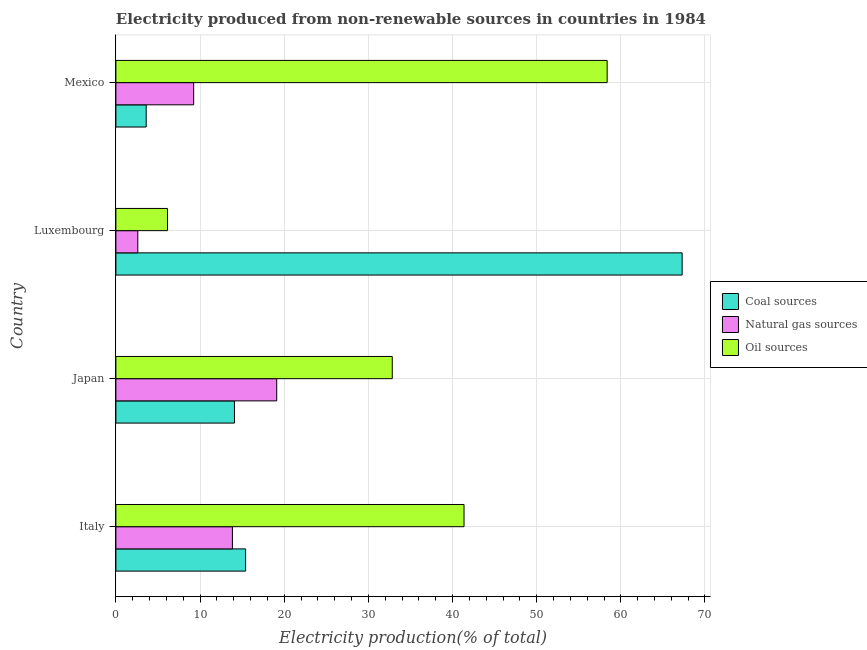How many different coloured bars are there?
Offer a very short reply. 3. How many groups of bars are there?
Provide a succinct answer. 4. Are the number of bars per tick equal to the number of legend labels?
Provide a short and direct response. Yes. What is the label of the 2nd group of bars from the top?
Your answer should be compact. Luxembourg. What is the percentage of electricity produced by natural gas in Mexico?
Ensure brevity in your answer.  9.24. Across all countries, what is the maximum percentage of electricity produced by oil sources?
Provide a succinct answer. 58.37. Across all countries, what is the minimum percentage of electricity produced by coal?
Your response must be concise. 3.6. In which country was the percentage of electricity produced by coal maximum?
Your response must be concise. Luxembourg. In which country was the percentage of electricity produced by coal minimum?
Ensure brevity in your answer.  Mexico. What is the total percentage of electricity produced by oil sources in the graph?
Your answer should be very brief. 138.72. What is the difference between the percentage of electricity produced by oil sources in Japan and that in Luxembourg?
Offer a terse response. 26.71. What is the difference between the percentage of electricity produced by natural gas in Luxembourg and the percentage of electricity produced by oil sources in Italy?
Offer a terse response. -38.77. What is the average percentage of electricity produced by natural gas per country?
Your response must be concise. 11.2. What is the difference between the percentage of electricity produced by coal and percentage of electricity produced by natural gas in Luxembourg?
Give a very brief answer. 64.68. What is the ratio of the percentage of electricity produced by coal in Japan to that in Luxembourg?
Give a very brief answer. 0.21. Is the percentage of electricity produced by natural gas in Japan less than that in Mexico?
Offer a very short reply. No. What is the difference between the highest and the second highest percentage of electricity produced by coal?
Ensure brevity in your answer.  51.87. What is the difference between the highest and the lowest percentage of electricity produced by oil sources?
Give a very brief answer. 52.24. In how many countries, is the percentage of electricity produced by natural gas greater than the average percentage of electricity produced by natural gas taken over all countries?
Provide a succinct answer. 2. Is the sum of the percentage of electricity produced by coal in Japan and Mexico greater than the maximum percentage of electricity produced by oil sources across all countries?
Offer a terse response. No. What does the 2nd bar from the top in Japan represents?
Provide a short and direct response. Natural gas sources. What does the 2nd bar from the bottom in Italy represents?
Keep it short and to the point. Natural gas sources. Is it the case that in every country, the sum of the percentage of electricity produced by coal and percentage of electricity produced by natural gas is greater than the percentage of electricity produced by oil sources?
Keep it short and to the point. No. Does the graph contain any zero values?
Your response must be concise. No. How many legend labels are there?
Give a very brief answer. 3. What is the title of the graph?
Ensure brevity in your answer.  Electricity produced from non-renewable sources in countries in 1984. What is the label or title of the Y-axis?
Offer a very short reply. Country. What is the Electricity production(% of total) of Coal sources in Italy?
Your answer should be very brief. 15.41. What is the Electricity production(% of total) in Natural gas sources in Italy?
Your answer should be very brief. 13.85. What is the Electricity production(% of total) in Oil sources in Italy?
Make the answer very short. 41.37. What is the Electricity production(% of total) in Coal sources in Japan?
Your response must be concise. 14.09. What is the Electricity production(% of total) in Natural gas sources in Japan?
Offer a terse response. 19.11. What is the Electricity production(% of total) of Oil sources in Japan?
Offer a very short reply. 32.84. What is the Electricity production(% of total) in Coal sources in Luxembourg?
Give a very brief answer. 67.29. What is the Electricity production(% of total) in Natural gas sources in Luxembourg?
Your answer should be very brief. 2.6. What is the Electricity production(% of total) in Oil sources in Luxembourg?
Ensure brevity in your answer.  6.13. What is the Electricity production(% of total) in Coal sources in Mexico?
Make the answer very short. 3.6. What is the Electricity production(% of total) of Natural gas sources in Mexico?
Offer a very short reply. 9.24. What is the Electricity production(% of total) in Oil sources in Mexico?
Offer a terse response. 58.37. Across all countries, what is the maximum Electricity production(% of total) in Coal sources?
Ensure brevity in your answer.  67.29. Across all countries, what is the maximum Electricity production(% of total) in Natural gas sources?
Provide a succinct answer. 19.11. Across all countries, what is the maximum Electricity production(% of total) in Oil sources?
Your response must be concise. 58.37. Across all countries, what is the minimum Electricity production(% of total) of Coal sources?
Ensure brevity in your answer.  3.6. Across all countries, what is the minimum Electricity production(% of total) of Natural gas sources?
Ensure brevity in your answer.  2.6. Across all countries, what is the minimum Electricity production(% of total) of Oil sources?
Offer a very short reply. 6.13. What is the total Electricity production(% of total) in Coal sources in the graph?
Make the answer very short. 100.39. What is the total Electricity production(% of total) of Natural gas sources in the graph?
Your answer should be very brief. 44.8. What is the total Electricity production(% of total) of Oil sources in the graph?
Provide a succinct answer. 138.72. What is the difference between the Electricity production(% of total) in Coal sources in Italy and that in Japan?
Ensure brevity in your answer.  1.33. What is the difference between the Electricity production(% of total) of Natural gas sources in Italy and that in Japan?
Provide a short and direct response. -5.26. What is the difference between the Electricity production(% of total) in Oil sources in Italy and that in Japan?
Your answer should be compact. 8.53. What is the difference between the Electricity production(% of total) of Coal sources in Italy and that in Luxembourg?
Provide a short and direct response. -51.87. What is the difference between the Electricity production(% of total) of Natural gas sources in Italy and that in Luxembourg?
Your answer should be very brief. 11.24. What is the difference between the Electricity production(% of total) of Oil sources in Italy and that in Luxembourg?
Provide a succinct answer. 35.23. What is the difference between the Electricity production(% of total) of Coal sources in Italy and that in Mexico?
Ensure brevity in your answer.  11.81. What is the difference between the Electricity production(% of total) of Natural gas sources in Italy and that in Mexico?
Give a very brief answer. 4.6. What is the difference between the Electricity production(% of total) in Oil sources in Italy and that in Mexico?
Keep it short and to the point. -17.01. What is the difference between the Electricity production(% of total) of Coal sources in Japan and that in Luxembourg?
Ensure brevity in your answer.  -53.2. What is the difference between the Electricity production(% of total) in Natural gas sources in Japan and that in Luxembourg?
Keep it short and to the point. 16.51. What is the difference between the Electricity production(% of total) in Oil sources in Japan and that in Luxembourg?
Ensure brevity in your answer.  26.71. What is the difference between the Electricity production(% of total) in Coal sources in Japan and that in Mexico?
Provide a short and direct response. 10.49. What is the difference between the Electricity production(% of total) in Natural gas sources in Japan and that in Mexico?
Give a very brief answer. 9.87. What is the difference between the Electricity production(% of total) of Oil sources in Japan and that in Mexico?
Provide a short and direct response. -25.53. What is the difference between the Electricity production(% of total) in Coal sources in Luxembourg and that in Mexico?
Make the answer very short. 63.68. What is the difference between the Electricity production(% of total) in Natural gas sources in Luxembourg and that in Mexico?
Make the answer very short. -6.64. What is the difference between the Electricity production(% of total) in Oil sources in Luxembourg and that in Mexico?
Keep it short and to the point. -52.24. What is the difference between the Electricity production(% of total) of Coal sources in Italy and the Electricity production(% of total) of Natural gas sources in Japan?
Provide a short and direct response. -3.7. What is the difference between the Electricity production(% of total) in Coal sources in Italy and the Electricity production(% of total) in Oil sources in Japan?
Your answer should be compact. -17.43. What is the difference between the Electricity production(% of total) in Natural gas sources in Italy and the Electricity production(% of total) in Oil sources in Japan?
Your answer should be very brief. -18.99. What is the difference between the Electricity production(% of total) of Coal sources in Italy and the Electricity production(% of total) of Natural gas sources in Luxembourg?
Your answer should be compact. 12.81. What is the difference between the Electricity production(% of total) of Coal sources in Italy and the Electricity production(% of total) of Oil sources in Luxembourg?
Make the answer very short. 9.28. What is the difference between the Electricity production(% of total) in Natural gas sources in Italy and the Electricity production(% of total) in Oil sources in Luxembourg?
Your response must be concise. 7.71. What is the difference between the Electricity production(% of total) of Coal sources in Italy and the Electricity production(% of total) of Natural gas sources in Mexico?
Make the answer very short. 6.17. What is the difference between the Electricity production(% of total) in Coal sources in Italy and the Electricity production(% of total) in Oil sources in Mexico?
Provide a succinct answer. -42.96. What is the difference between the Electricity production(% of total) of Natural gas sources in Italy and the Electricity production(% of total) of Oil sources in Mexico?
Your response must be concise. -44.53. What is the difference between the Electricity production(% of total) in Coal sources in Japan and the Electricity production(% of total) in Natural gas sources in Luxembourg?
Your answer should be compact. 11.49. What is the difference between the Electricity production(% of total) of Coal sources in Japan and the Electricity production(% of total) of Oil sources in Luxembourg?
Offer a very short reply. 7.95. What is the difference between the Electricity production(% of total) of Natural gas sources in Japan and the Electricity production(% of total) of Oil sources in Luxembourg?
Offer a terse response. 12.98. What is the difference between the Electricity production(% of total) of Coal sources in Japan and the Electricity production(% of total) of Natural gas sources in Mexico?
Ensure brevity in your answer.  4.85. What is the difference between the Electricity production(% of total) of Coal sources in Japan and the Electricity production(% of total) of Oil sources in Mexico?
Offer a very short reply. -44.29. What is the difference between the Electricity production(% of total) of Natural gas sources in Japan and the Electricity production(% of total) of Oil sources in Mexico?
Ensure brevity in your answer.  -39.26. What is the difference between the Electricity production(% of total) of Coal sources in Luxembourg and the Electricity production(% of total) of Natural gas sources in Mexico?
Keep it short and to the point. 58.04. What is the difference between the Electricity production(% of total) in Coal sources in Luxembourg and the Electricity production(% of total) in Oil sources in Mexico?
Provide a short and direct response. 8.91. What is the difference between the Electricity production(% of total) of Natural gas sources in Luxembourg and the Electricity production(% of total) of Oil sources in Mexico?
Offer a terse response. -55.77. What is the average Electricity production(% of total) of Coal sources per country?
Keep it short and to the point. 25.1. What is the average Electricity production(% of total) in Natural gas sources per country?
Provide a succinct answer. 11.2. What is the average Electricity production(% of total) of Oil sources per country?
Offer a terse response. 34.68. What is the difference between the Electricity production(% of total) in Coal sources and Electricity production(% of total) in Natural gas sources in Italy?
Make the answer very short. 1.57. What is the difference between the Electricity production(% of total) of Coal sources and Electricity production(% of total) of Oil sources in Italy?
Ensure brevity in your answer.  -25.95. What is the difference between the Electricity production(% of total) in Natural gas sources and Electricity production(% of total) in Oil sources in Italy?
Give a very brief answer. -27.52. What is the difference between the Electricity production(% of total) in Coal sources and Electricity production(% of total) in Natural gas sources in Japan?
Make the answer very short. -5.02. What is the difference between the Electricity production(% of total) in Coal sources and Electricity production(% of total) in Oil sources in Japan?
Provide a succinct answer. -18.75. What is the difference between the Electricity production(% of total) of Natural gas sources and Electricity production(% of total) of Oil sources in Japan?
Your answer should be very brief. -13.73. What is the difference between the Electricity production(% of total) of Coal sources and Electricity production(% of total) of Natural gas sources in Luxembourg?
Make the answer very short. 64.68. What is the difference between the Electricity production(% of total) of Coal sources and Electricity production(% of total) of Oil sources in Luxembourg?
Give a very brief answer. 61.15. What is the difference between the Electricity production(% of total) of Natural gas sources and Electricity production(% of total) of Oil sources in Luxembourg?
Offer a very short reply. -3.53. What is the difference between the Electricity production(% of total) of Coal sources and Electricity production(% of total) of Natural gas sources in Mexico?
Make the answer very short. -5.64. What is the difference between the Electricity production(% of total) in Coal sources and Electricity production(% of total) in Oil sources in Mexico?
Make the answer very short. -54.77. What is the difference between the Electricity production(% of total) in Natural gas sources and Electricity production(% of total) in Oil sources in Mexico?
Offer a terse response. -49.13. What is the ratio of the Electricity production(% of total) of Coal sources in Italy to that in Japan?
Your answer should be compact. 1.09. What is the ratio of the Electricity production(% of total) in Natural gas sources in Italy to that in Japan?
Give a very brief answer. 0.72. What is the ratio of the Electricity production(% of total) of Oil sources in Italy to that in Japan?
Provide a succinct answer. 1.26. What is the ratio of the Electricity production(% of total) of Coal sources in Italy to that in Luxembourg?
Give a very brief answer. 0.23. What is the ratio of the Electricity production(% of total) of Natural gas sources in Italy to that in Luxembourg?
Your answer should be compact. 5.32. What is the ratio of the Electricity production(% of total) of Oil sources in Italy to that in Luxembourg?
Provide a succinct answer. 6.74. What is the ratio of the Electricity production(% of total) of Coal sources in Italy to that in Mexico?
Your answer should be very brief. 4.28. What is the ratio of the Electricity production(% of total) of Natural gas sources in Italy to that in Mexico?
Ensure brevity in your answer.  1.5. What is the ratio of the Electricity production(% of total) of Oil sources in Italy to that in Mexico?
Provide a succinct answer. 0.71. What is the ratio of the Electricity production(% of total) of Coal sources in Japan to that in Luxembourg?
Offer a very short reply. 0.21. What is the ratio of the Electricity production(% of total) in Natural gas sources in Japan to that in Luxembourg?
Your response must be concise. 7.34. What is the ratio of the Electricity production(% of total) in Oil sources in Japan to that in Luxembourg?
Offer a terse response. 5.35. What is the ratio of the Electricity production(% of total) of Coal sources in Japan to that in Mexico?
Your answer should be compact. 3.91. What is the ratio of the Electricity production(% of total) of Natural gas sources in Japan to that in Mexico?
Ensure brevity in your answer.  2.07. What is the ratio of the Electricity production(% of total) in Oil sources in Japan to that in Mexico?
Offer a very short reply. 0.56. What is the ratio of the Electricity production(% of total) in Coal sources in Luxembourg to that in Mexico?
Your response must be concise. 18.68. What is the ratio of the Electricity production(% of total) of Natural gas sources in Luxembourg to that in Mexico?
Your response must be concise. 0.28. What is the ratio of the Electricity production(% of total) of Oil sources in Luxembourg to that in Mexico?
Your response must be concise. 0.11. What is the difference between the highest and the second highest Electricity production(% of total) of Coal sources?
Your answer should be very brief. 51.87. What is the difference between the highest and the second highest Electricity production(% of total) of Natural gas sources?
Make the answer very short. 5.26. What is the difference between the highest and the second highest Electricity production(% of total) in Oil sources?
Ensure brevity in your answer.  17.01. What is the difference between the highest and the lowest Electricity production(% of total) in Coal sources?
Your answer should be very brief. 63.68. What is the difference between the highest and the lowest Electricity production(% of total) of Natural gas sources?
Offer a terse response. 16.51. What is the difference between the highest and the lowest Electricity production(% of total) of Oil sources?
Offer a very short reply. 52.24. 